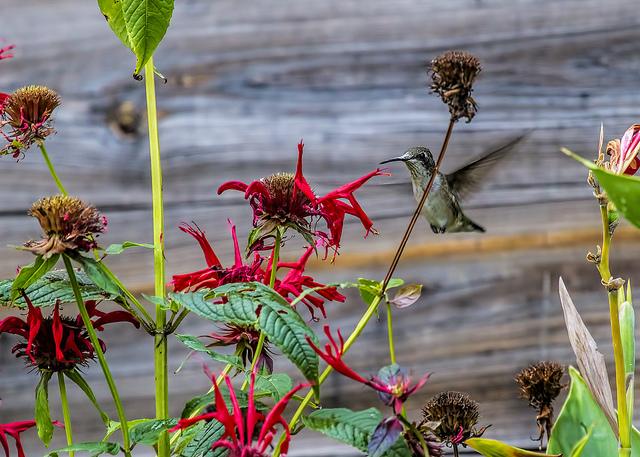What color is the flower the bird is interested in?
Short answer required. Red. How many birds are there?
Concise answer only. 1. What is the  name of the bird?
Give a very brief answer. Hummingbird. 